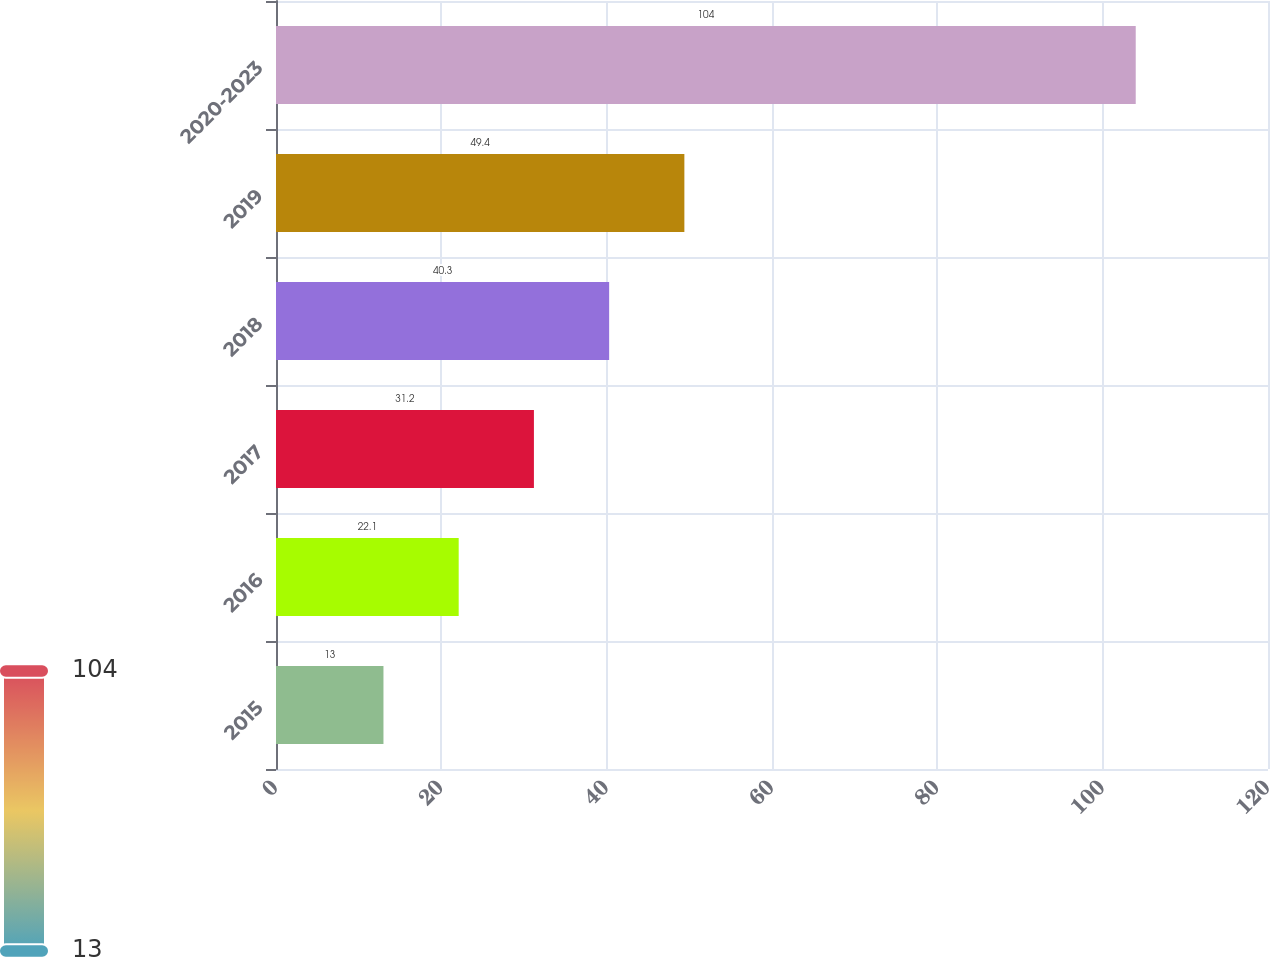Convert chart to OTSL. <chart><loc_0><loc_0><loc_500><loc_500><bar_chart><fcel>2015<fcel>2016<fcel>2017<fcel>2018<fcel>2019<fcel>2020-2023<nl><fcel>13<fcel>22.1<fcel>31.2<fcel>40.3<fcel>49.4<fcel>104<nl></chart> 